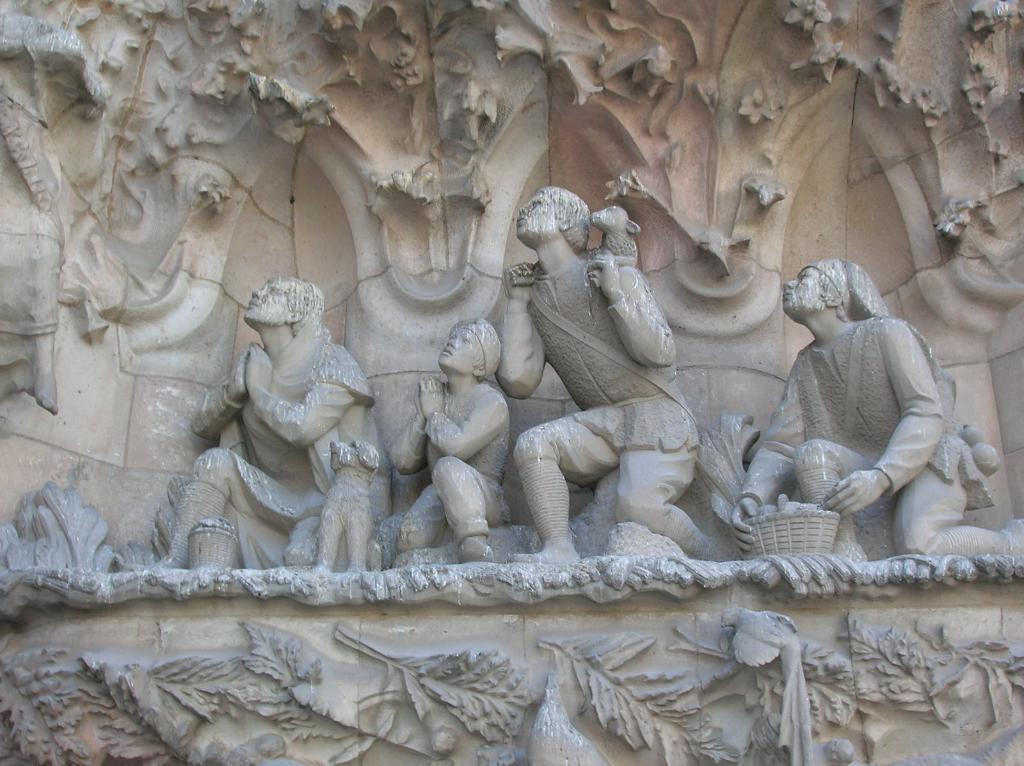What is the main subject of the image? There is a statue of a person in the image. Where is the statue located in relation to other objects? The statue is near a wall. What other significant structure can be seen in the image? There is a monument visible in the image. What decorative elements are present at the bottom of the image? Designs of plants, birds, and leaves are present at the bottom of the image. What type of umbrella is being used by the statue in the image? There is no umbrella present in the image; the statue is not holding or using any umbrella. What kind of net is draped over the monument in the image? There is no net present in the image; the monument is not covered or draped with any net. 